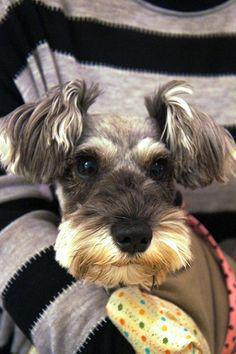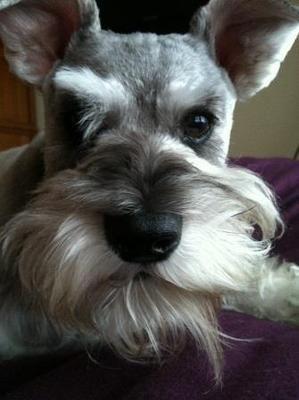The first image is the image on the left, the second image is the image on the right. For the images shown, is this caption "An image shows a frontward-facing schnauzer wearing a collar." true? Answer yes or no. No. 